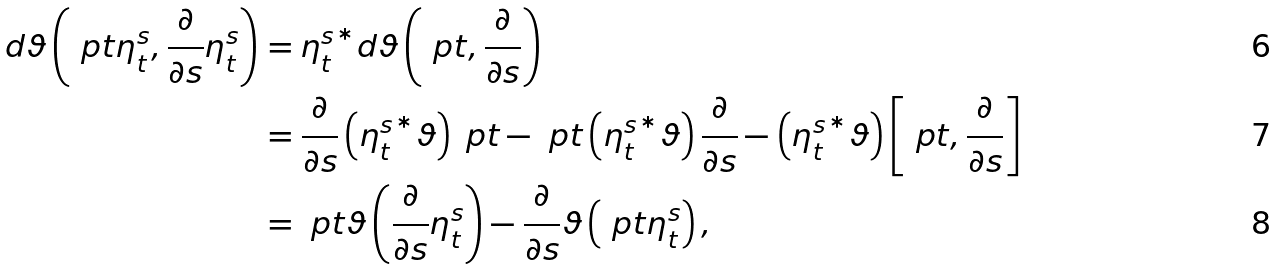Convert formula to latex. <formula><loc_0><loc_0><loc_500><loc_500>d \vartheta \left ( \ p t \eta _ { t } ^ { s } , \frac { \partial } { \partial s } \eta _ { t } ^ { s } \right ) & = { \eta _ { t } ^ { s } } ^ { * } d \vartheta \left ( \ p t , \frac { \partial } { \partial s } \right ) \\ & = \frac { \partial } { \partial s } \left ( { \eta _ { t } ^ { s } } ^ { * } \vartheta \right ) \ p t - \ p t \left ( { \eta _ { t } ^ { s } } ^ { * } \vartheta \right ) \frac { \partial } { \partial s } - \left ( { \eta _ { t } ^ { s } } ^ { * } \vartheta \right ) \left [ \ p t , \frac { \partial } { \partial s } \right ] \\ & = \ p t \vartheta \left ( \frac { \partial } { \partial s } \eta _ { t } ^ { s } \right ) - \frac { \partial } { \partial s } \vartheta \left ( \ p t \eta _ { t } ^ { s } \right ) ,</formula> 